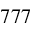Convert formula to latex. <formula><loc_0><loc_0><loc_500><loc_500>7 7 7</formula> 